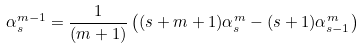Convert formula to latex. <formula><loc_0><loc_0><loc_500><loc_500>\alpha _ { s } ^ { m - 1 } = \frac { 1 } { ( m + 1 ) } \left ( ( s + m + 1 ) \alpha _ { s } ^ { m } - ( s + 1 ) \alpha _ { s - 1 } ^ { m } \right )</formula> 